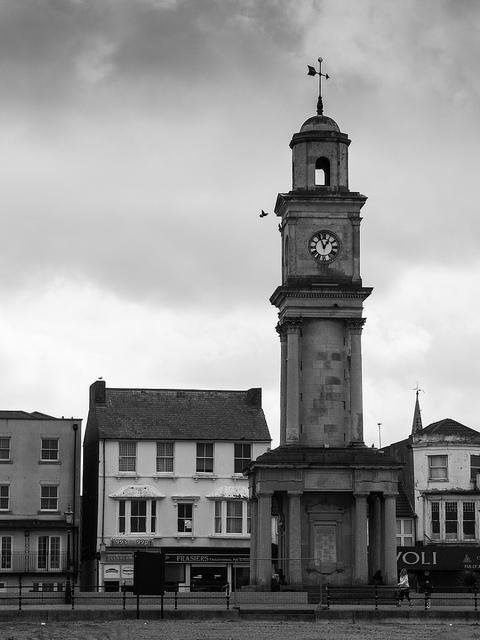What is the name for the cross shaped structure on top of the tower?
From the following set of four choices, select the accurate answer to respond to the question.
Options: Field thermometer, weather vane, tungsten cross, metric barometer. Weather vane. 